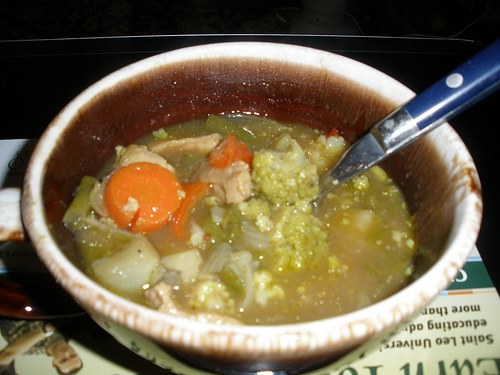Can you describe the overall context of the image? The image shows a bowl of hearty soup that appears to contain a rich mix of vegetables such as carrots, onions, and broccoli, along with chunks of meat. It provides a comforting and nutritious meal setting, possibly homemade, with a spoon to the right for easy consumption. 